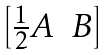Convert formula to latex. <formula><loc_0><loc_0><loc_500><loc_500>\begin{bmatrix} \frac { 1 } { 2 } A & B \end{bmatrix}</formula> 